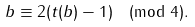Convert formula to latex. <formula><loc_0><loc_0><loc_500><loc_500>b \equiv 2 ( t ( b ) - 1 ) \pmod { 4 } .</formula> 